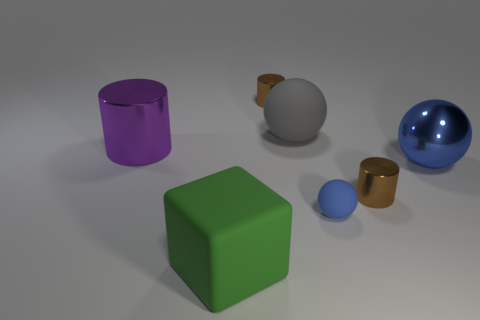How many brown metallic cylinders are behind the big metal ball?
Ensure brevity in your answer.  1. Do the tiny rubber ball and the metallic ball have the same color?
Keep it short and to the point. Yes. There is a small thing that is the same material as the green block; what is its shape?
Your answer should be very brief. Sphere. There is a small brown object that is right of the gray sphere; is its shape the same as the big green rubber thing?
Ensure brevity in your answer.  No. What number of green objects are tiny balls or big rubber objects?
Keep it short and to the point. 1. Are there the same number of gray matte objects in front of the purple thing and small brown cylinders to the right of the large green object?
Make the answer very short. No. What is the color of the big metal thing to the right of the tiny object that is on the left side of the gray sphere that is on the left side of the small ball?
Give a very brief answer. Blue. Are there any other things that are the same color as the large block?
Provide a short and direct response. No. What is the shape of the large shiny thing that is the same color as the small rubber sphere?
Your answer should be compact. Sphere. There is a brown cylinder behind the blue metallic ball; what size is it?
Keep it short and to the point. Small. 